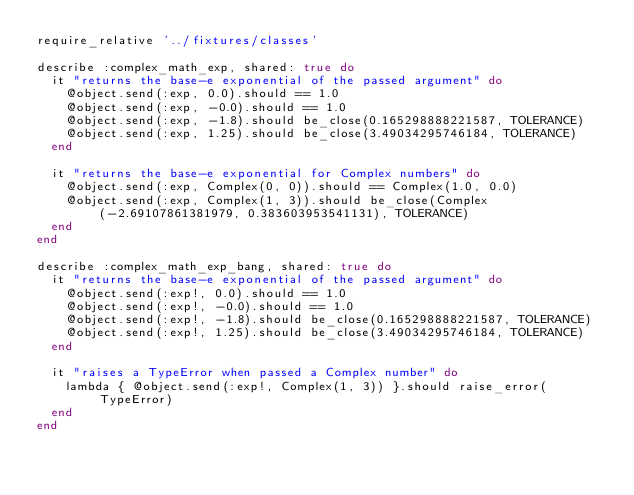Convert code to text. <code><loc_0><loc_0><loc_500><loc_500><_Ruby_>require_relative '../fixtures/classes'

describe :complex_math_exp, shared: true do
  it "returns the base-e exponential of the passed argument" do
    @object.send(:exp, 0.0).should == 1.0
    @object.send(:exp, -0.0).should == 1.0
    @object.send(:exp, -1.8).should be_close(0.165298888221587, TOLERANCE)
    @object.send(:exp, 1.25).should be_close(3.49034295746184, TOLERANCE)
  end

  it "returns the base-e exponential for Complex numbers" do
    @object.send(:exp, Complex(0, 0)).should == Complex(1.0, 0.0)
    @object.send(:exp, Complex(1, 3)).should be_close(Complex(-2.69107861381979, 0.383603953541131), TOLERANCE)
  end
end

describe :complex_math_exp_bang, shared: true do
  it "returns the base-e exponential of the passed argument" do
    @object.send(:exp!, 0.0).should == 1.0
    @object.send(:exp!, -0.0).should == 1.0
    @object.send(:exp!, -1.8).should be_close(0.165298888221587, TOLERANCE)
    @object.send(:exp!, 1.25).should be_close(3.49034295746184, TOLERANCE)
  end

  it "raises a TypeError when passed a Complex number" do
    lambda { @object.send(:exp!, Complex(1, 3)) }.should raise_error(TypeError)
  end
end
</code> 